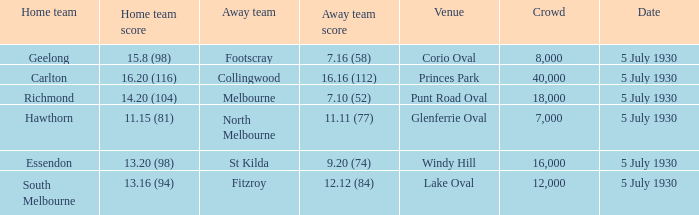Who is the away side at corio oval? Footscray. 